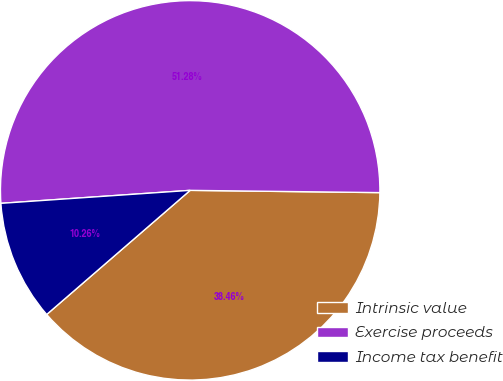<chart> <loc_0><loc_0><loc_500><loc_500><pie_chart><fcel>Intrinsic value<fcel>Exercise proceeds<fcel>Income tax benefit<nl><fcel>38.46%<fcel>51.28%<fcel>10.26%<nl></chart> 